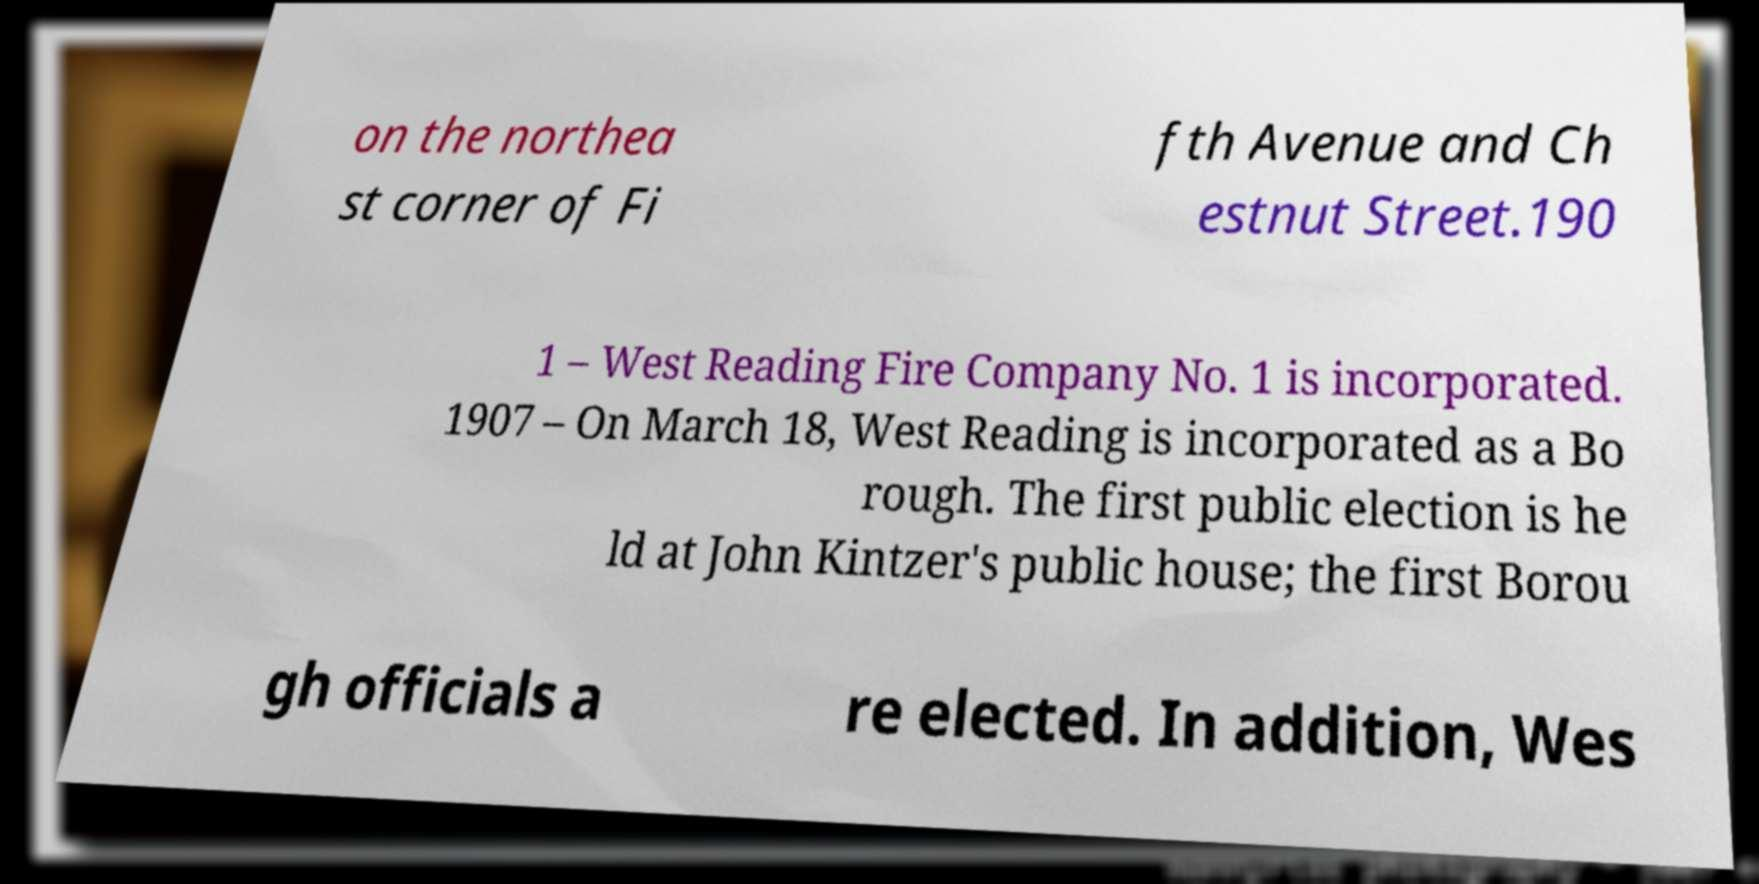There's text embedded in this image that I need extracted. Can you transcribe it verbatim? on the northea st corner of Fi fth Avenue and Ch estnut Street.190 1 – West Reading Fire Company No. 1 is incorporated. 1907 – On March 18, West Reading is incorporated as a Bo rough. The first public election is he ld at John Kintzer's public house; the first Borou gh officials a re elected. In addition, Wes 